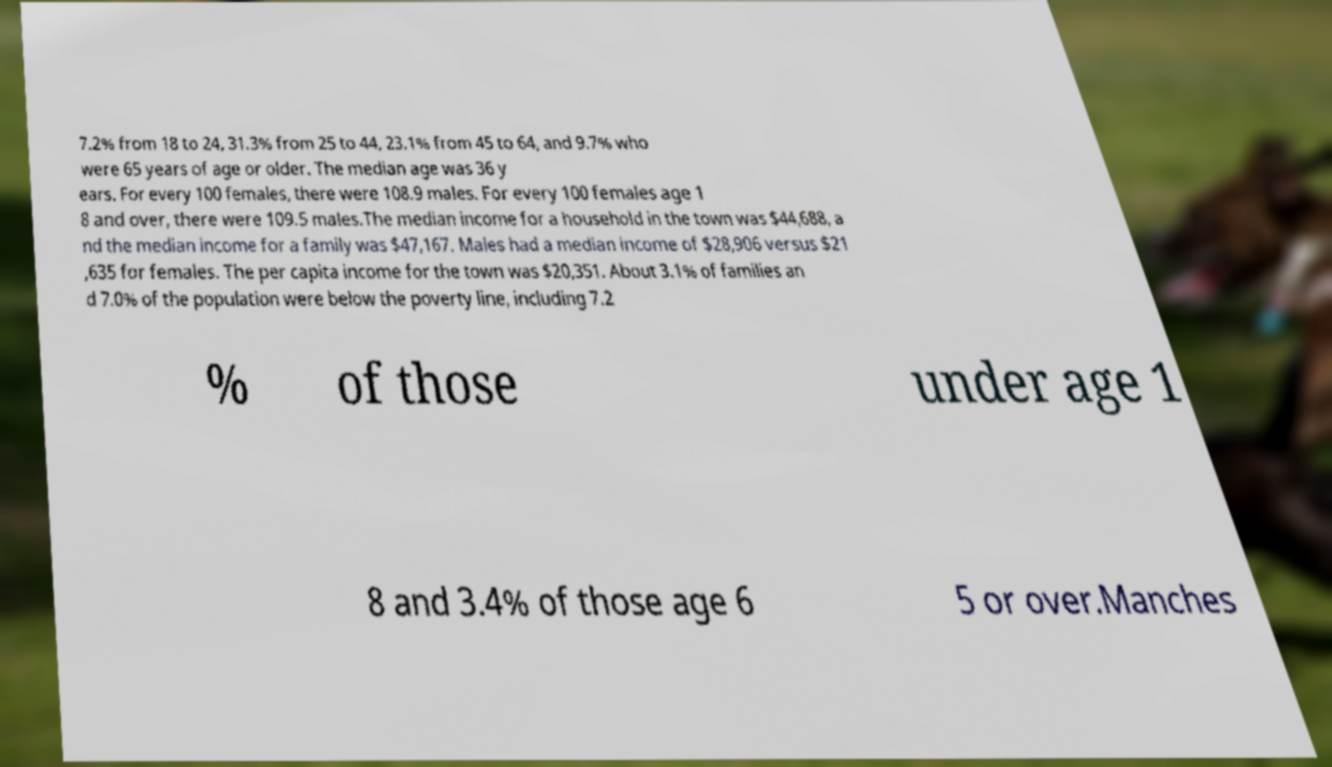Please read and relay the text visible in this image. What does it say? 7.2% from 18 to 24, 31.3% from 25 to 44, 23.1% from 45 to 64, and 9.7% who were 65 years of age or older. The median age was 36 y ears. For every 100 females, there were 108.9 males. For every 100 females age 1 8 and over, there were 109.5 males.The median income for a household in the town was $44,688, a nd the median income for a family was $47,167. Males had a median income of $28,906 versus $21 ,635 for females. The per capita income for the town was $20,351. About 3.1% of families an d 7.0% of the population were below the poverty line, including 7.2 % of those under age 1 8 and 3.4% of those age 6 5 or over.Manches 